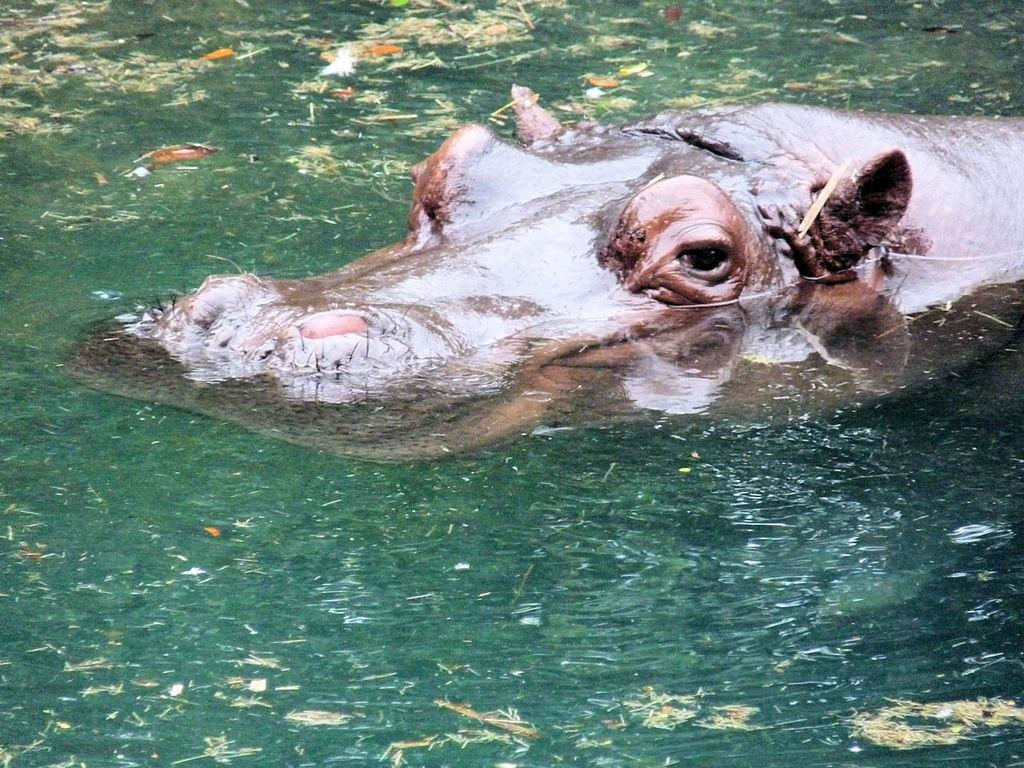What type of animal can be seen in the image? There is an animal in the image, but its specific type cannot be determined from the provided facts. What color is the animal in the image? The animal is brown in color. Where is the animal located in the image? The animal is in the water. What color is the water in the image? The water is green in color. What type of vegetation is visible in the image? There is grass visible in the image. What else can be seen floating on the water's surface? There are leaves on the surface of the water. What does the alley taste like in the image? There is no alley present in the image, so it cannot be tasted. How does the drain affect the water's flow in the image? There is no drain present in the image, so its effect on the water's flow cannot be determined. 